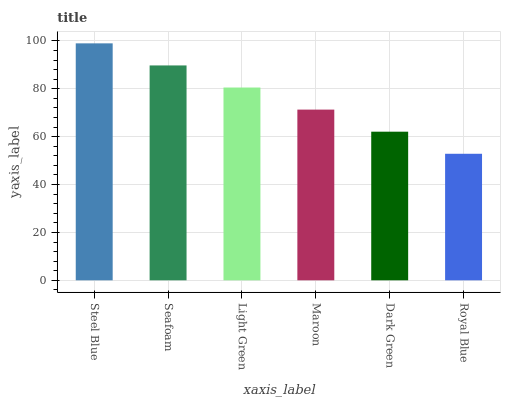Is Royal Blue the minimum?
Answer yes or no. Yes. Is Steel Blue the maximum?
Answer yes or no. Yes. Is Seafoam the minimum?
Answer yes or no. No. Is Seafoam the maximum?
Answer yes or no. No. Is Steel Blue greater than Seafoam?
Answer yes or no. Yes. Is Seafoam less than Steel Blue?
Answer yes or no. Yes. Is Seafoam greater than Steel Blue?
Answer yes or no. No. Is Steel Blue less than Seafoam?
Answer yes or no. No. Is Light Green the high median?
Answer yes or no. Yes. Is Maroon the low median?
Answer yes or no. Yes. Is Dark Green the high median?
Answer yes or no. No. Is Light Green the low median?
Answer yes or no. No. 